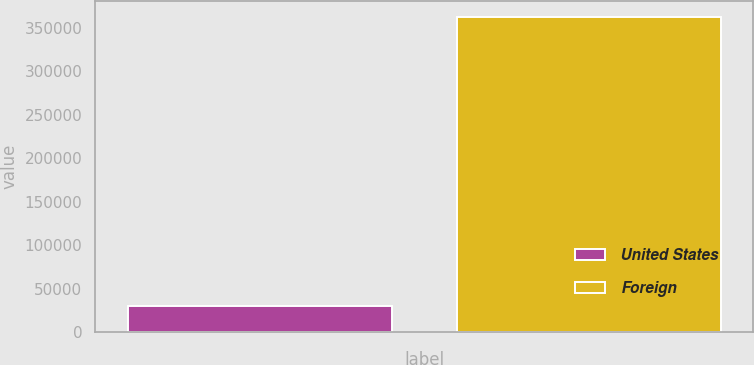Convert chart to OTSL. <chart><loc_0><loc_0><loc_500><loc_500><bar_chart><fcel>United States<fcel>Foreign<nl><fcel>29692<fcel>362991<nl></chart> 